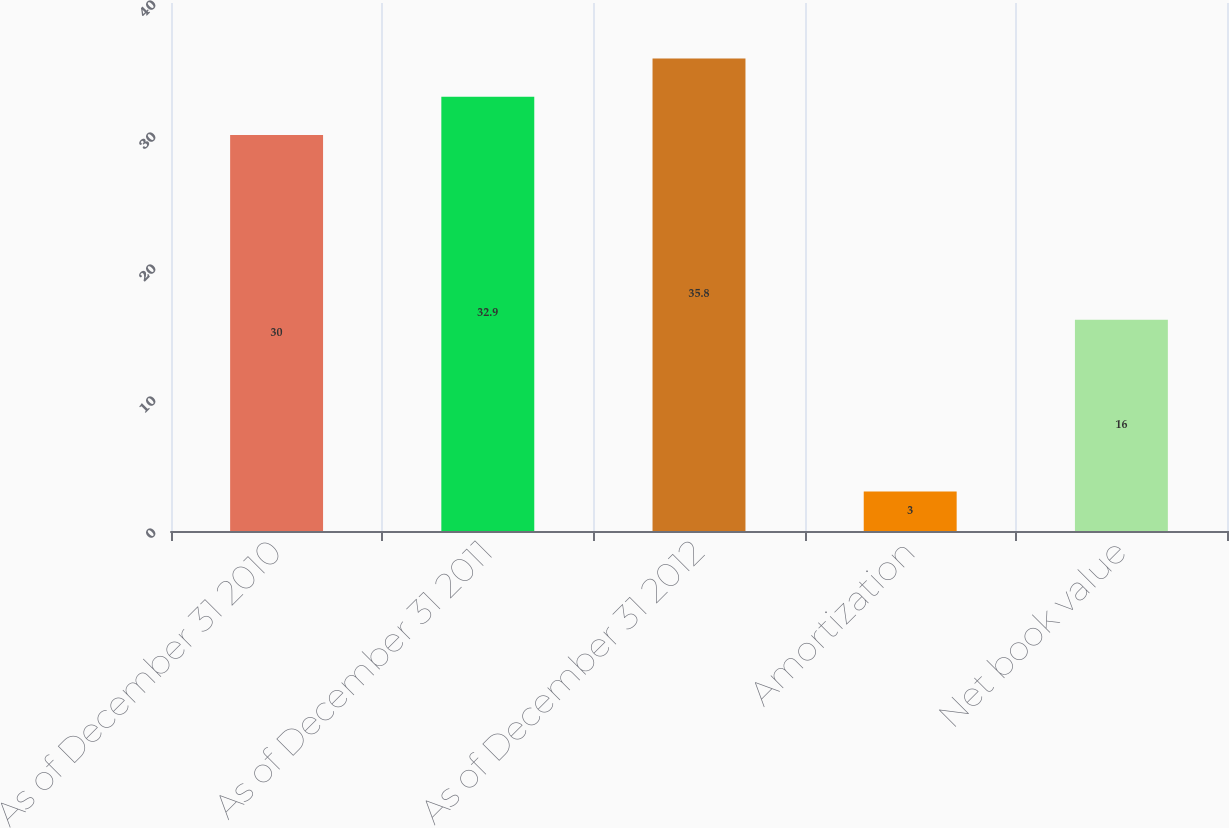Convert chart. <chart><loc_0><loc_0><loc_500><loc_500><bar_chart><fcel>As of December 31 2010<fcel>As of December 31 2011<fcel>As of December 31 2012<fcel>Amortization<fcel>Net book value<nl><fcel>30<fcel>32.9<fcel>35.8<fcel>3<fcel>16<nl></chart> 